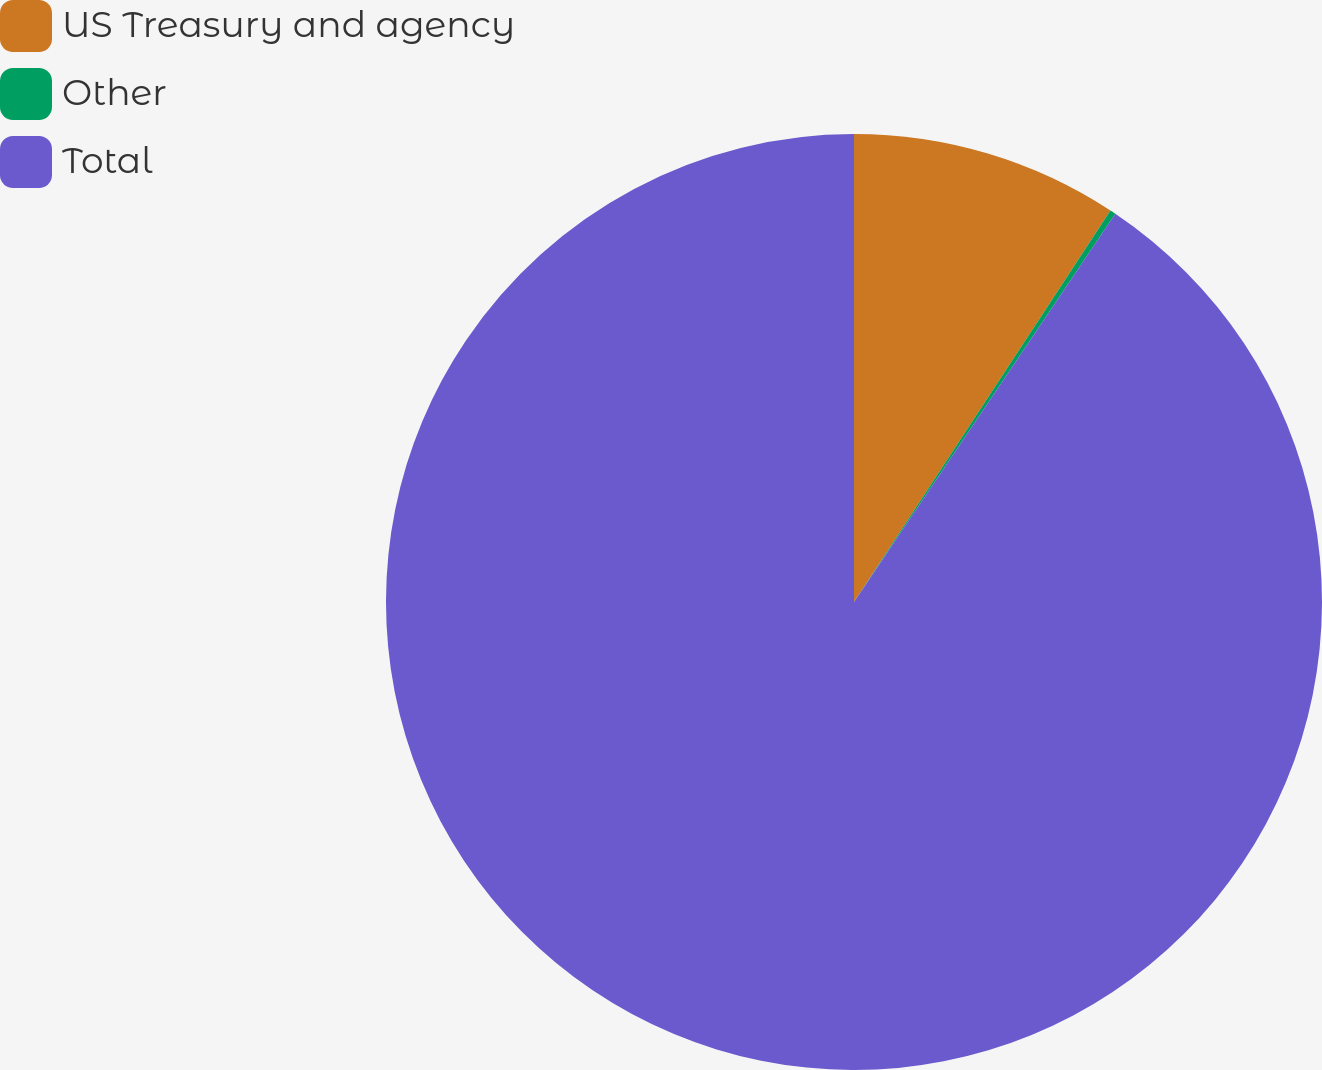Convert chart to OTSL. <chart><loc_0><loc_0><loc_500><loc_500><pie_chart><fcel>US Treasury and agency<fcel>Other<fcel>Total<nl><fcel>9.23%<fcel>0.2%<fcel>90.57%<nl></chart> 